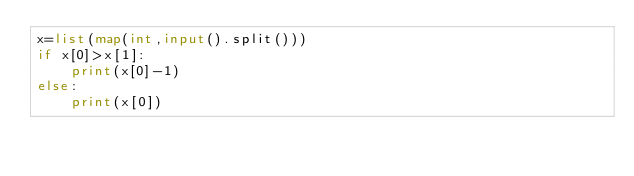<code> <loc_0><loc_0><loc_500><loc_500><_Python_>x=list(map(int,input().split()))
if x[0]>x[1]:
    print(x[0]-1)
else:
    print(x[0])</code> 